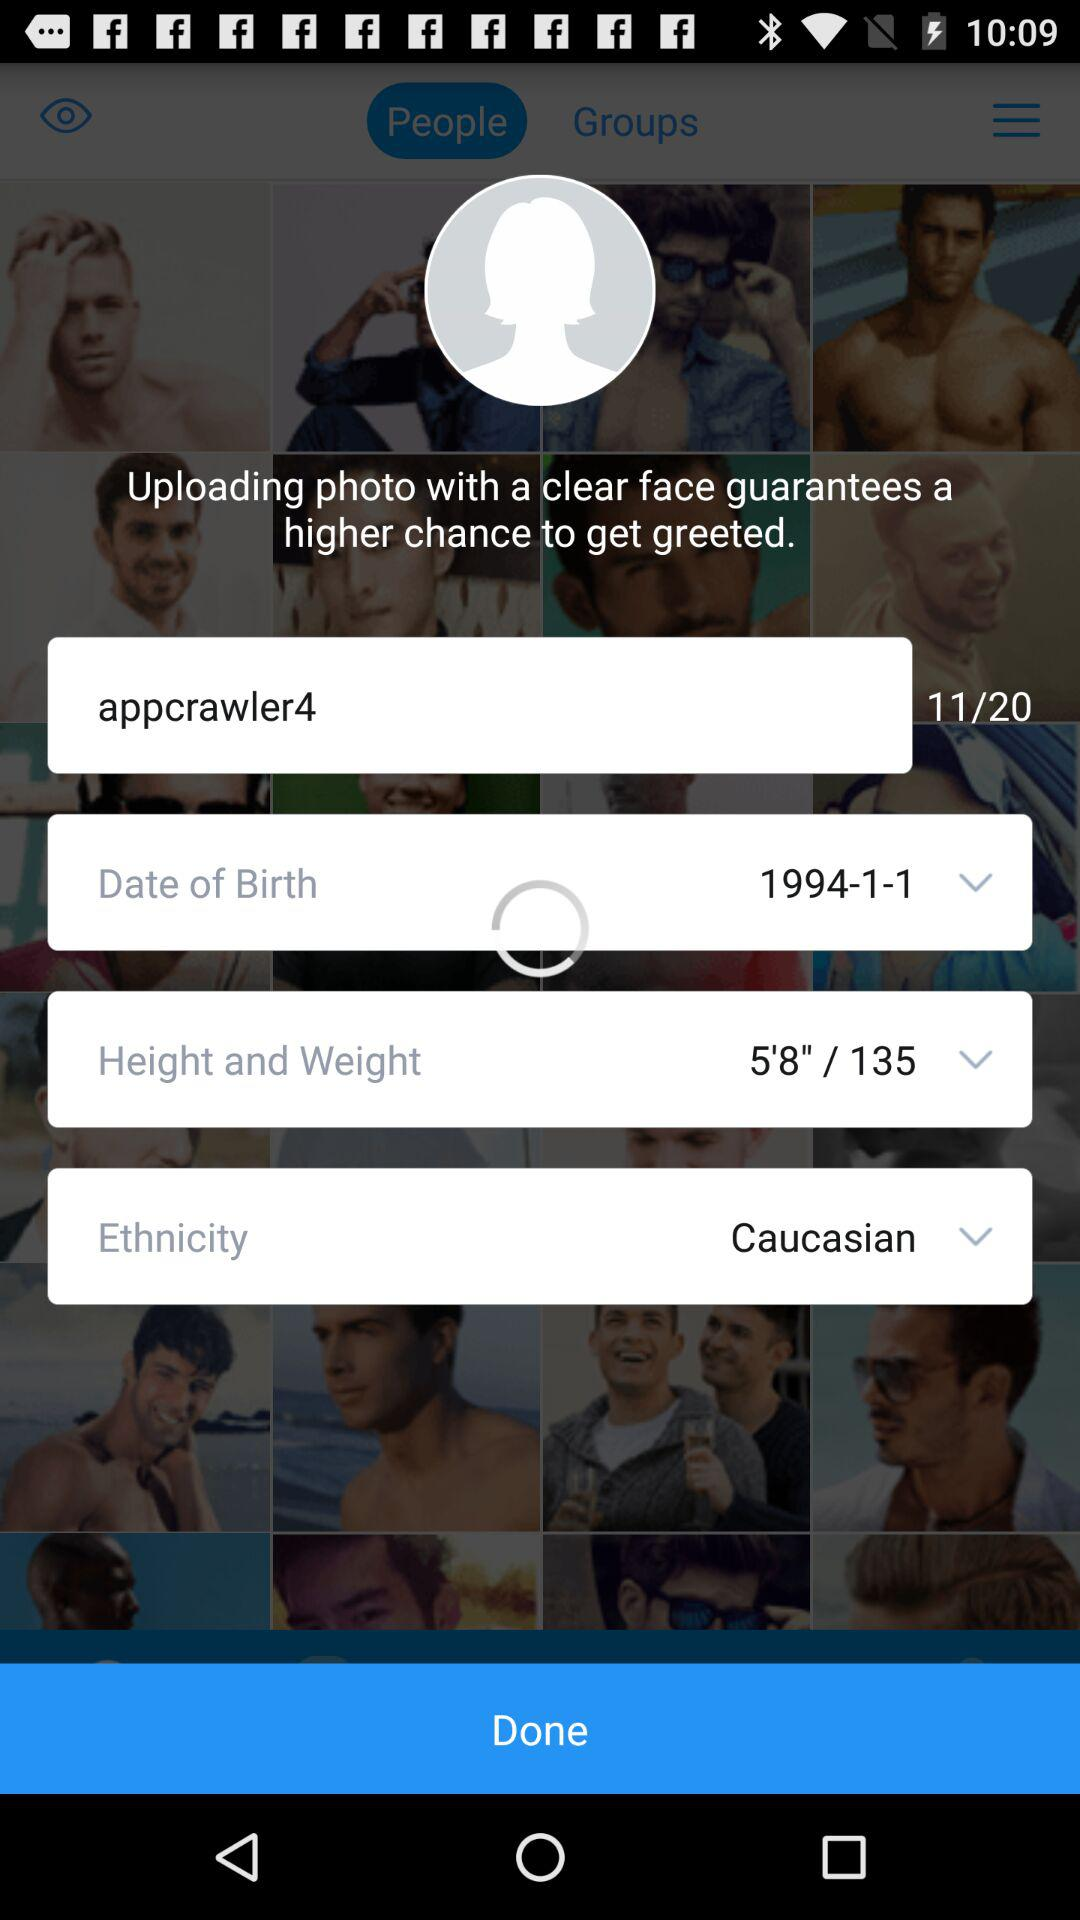What application can we use to log in? You can log in with Facebook. 